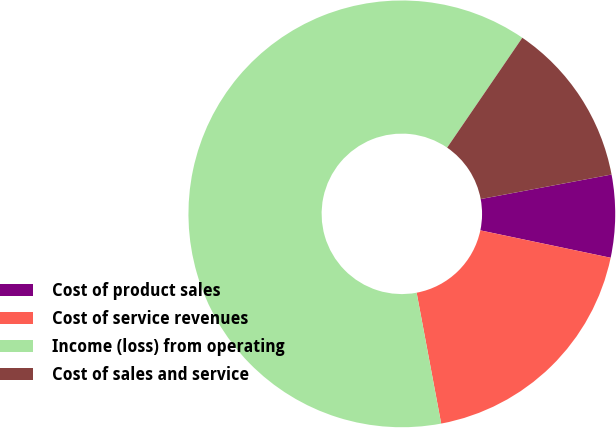Convert chart to OTSL. <chart><loc_0><loc_0><loc_500><loc_500><pie_chart><fcel>Cost of product sales<fcel>Cost of service revenues<fcel>Income (loss) from operating<fcel>Cost of sales and service<nl><fcel>6.25%<fcel>18.75%<fcel>62.5%<fcel>12.5%<nl></chart> 